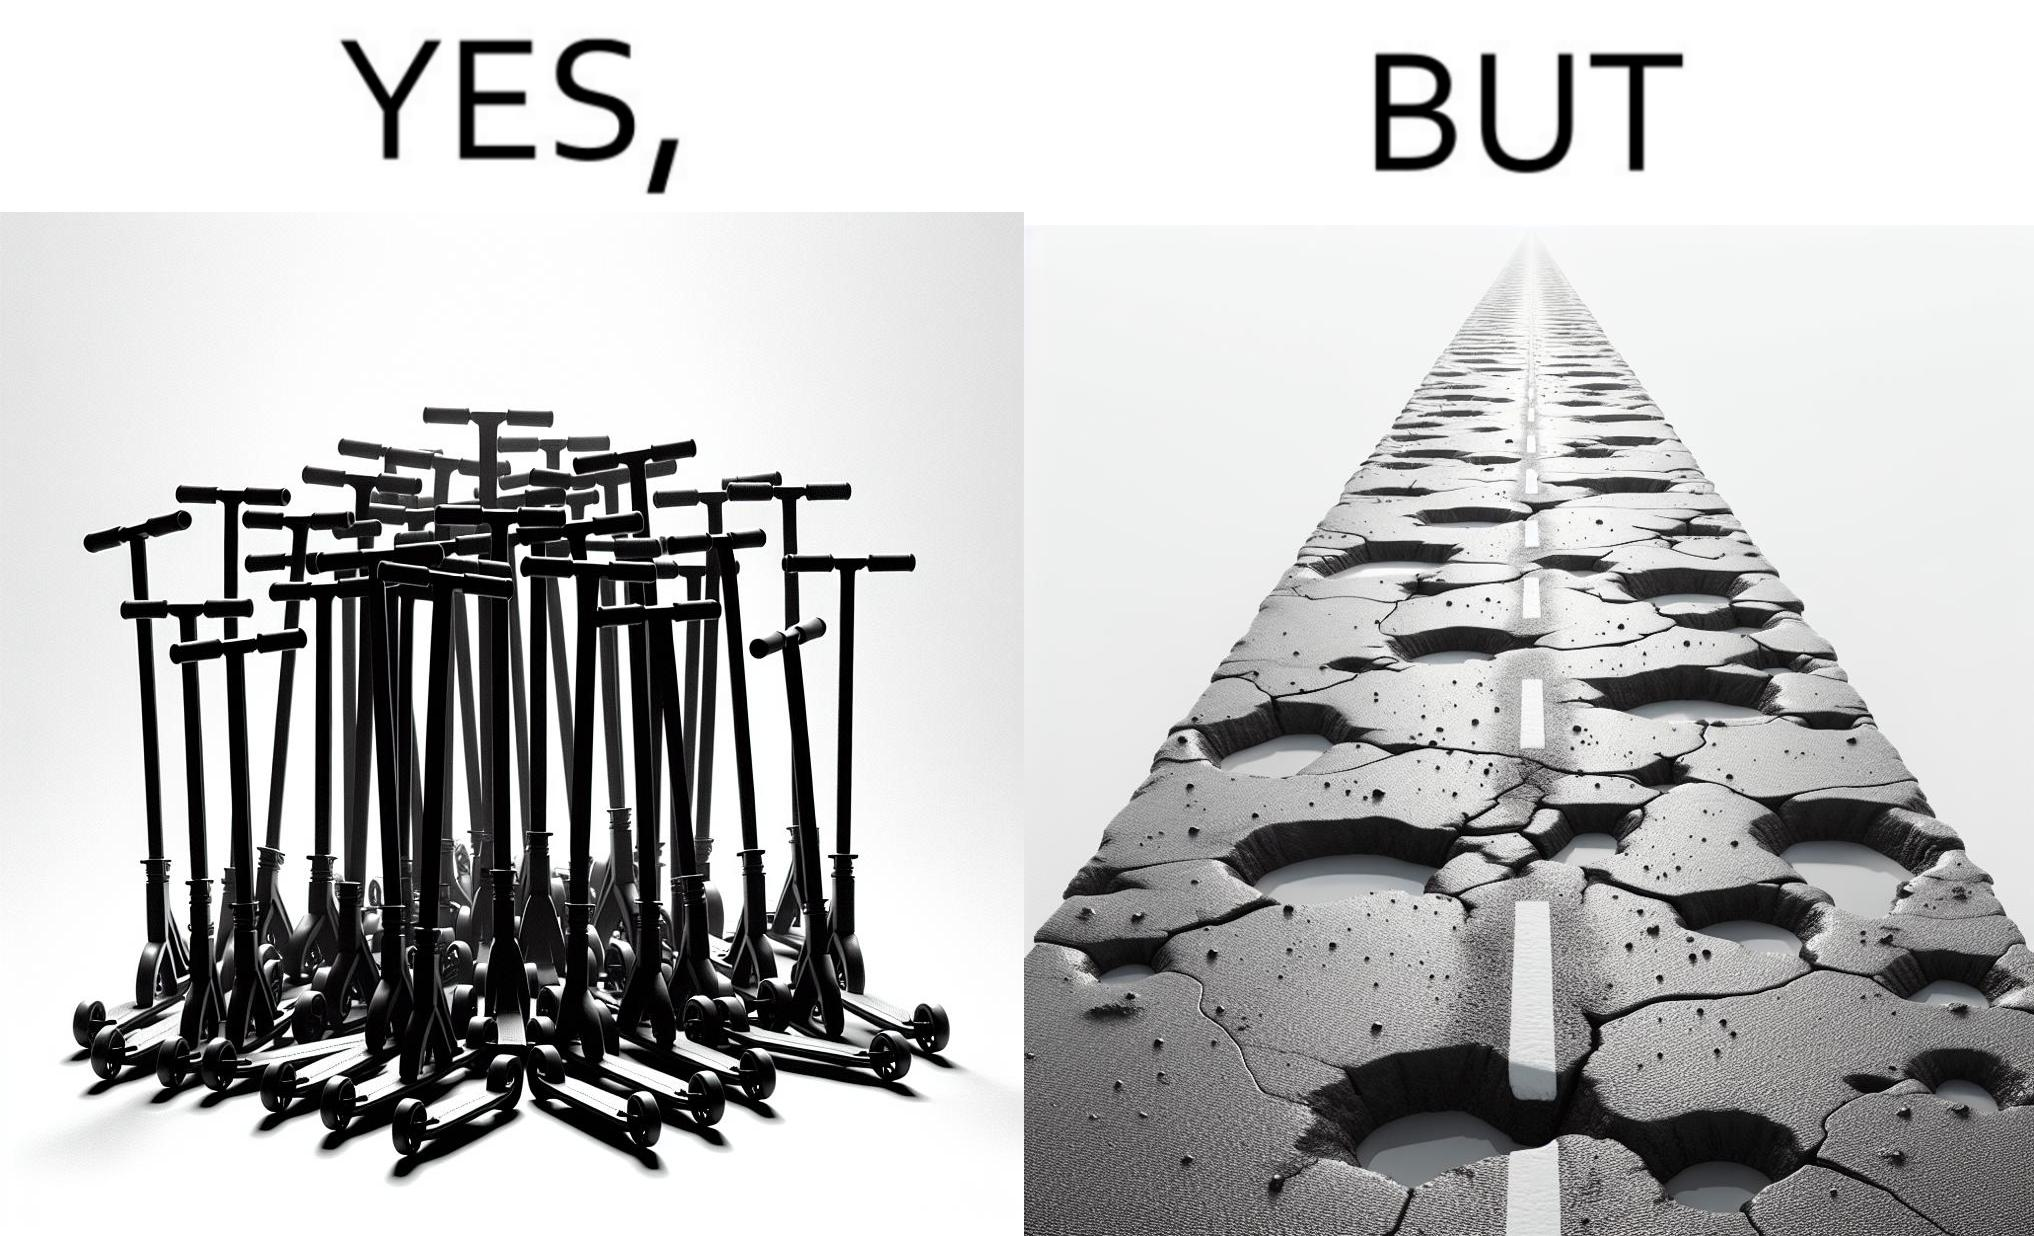Describe the content of this image. The image is ironic, because even after when the skateboard scooters are available for someone to ride but the road has many potholes that it is not suitable to ride the scooters on such roads 